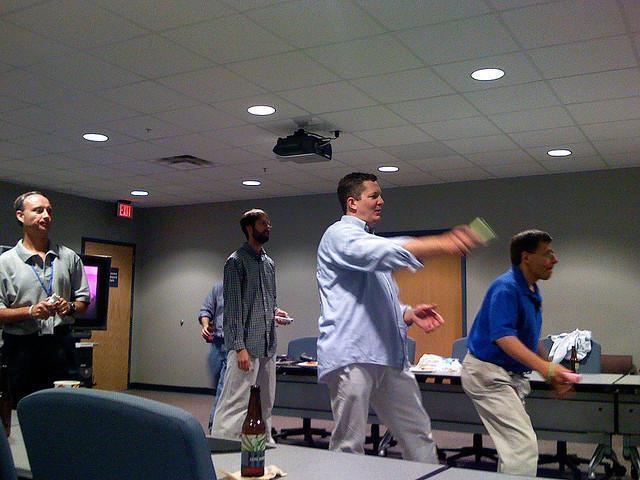What is everyone doing standing with remotes?
Answer the question by selecting the correct answer among the 4 following choices.
Options: Changing television, power point, video gaming, calisthenics. Video gaming. 